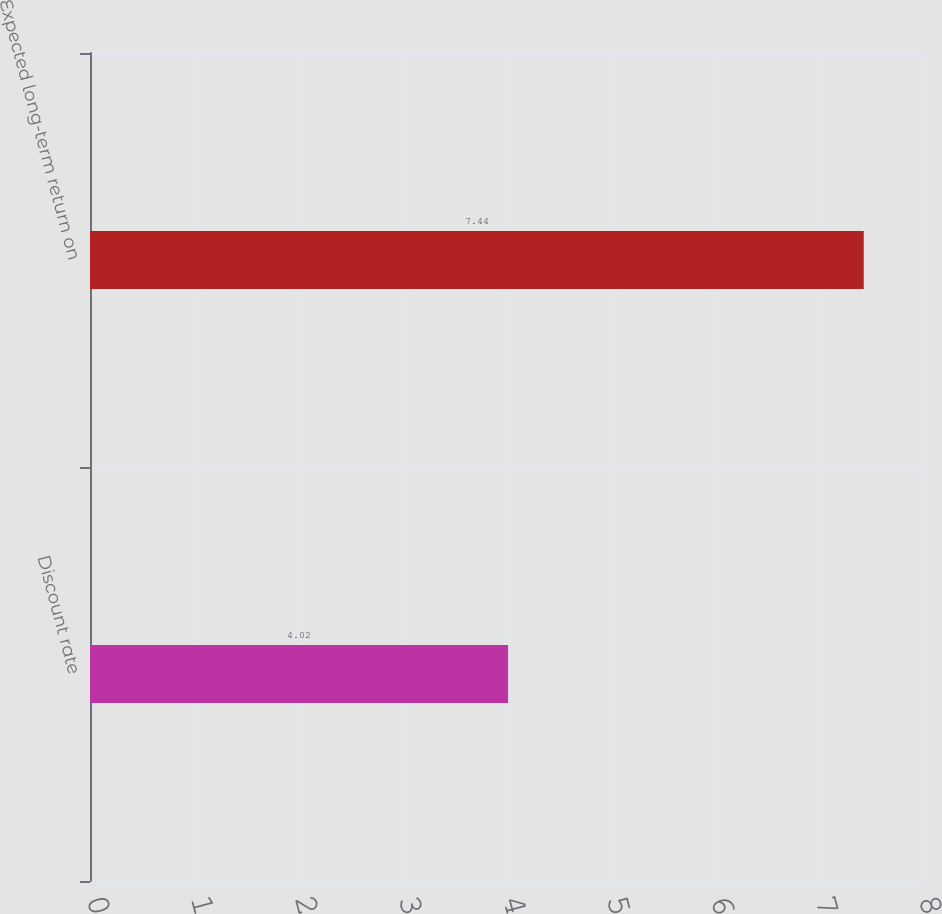Convert chart to OTSL. <chart><loc_0><loc_0><loc_500><loc_500><bar_chart><fcel>Discount rate<fcel>Expected long-term return on<nl><fcel>4.02<fcel>7.44<nl></chart> 